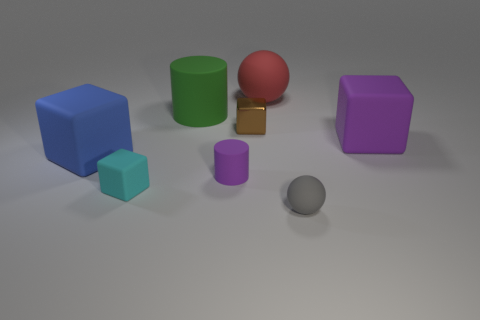Subtract all small rubber blocks. How many blocks are left? 3 Add 1 tiny matte objects. How many objects exist? 9 Subtract all yellow cubes. Subtract all yellow cylinders. How many cubes are left? 4 Subtract all spheres. How many objects are left? 6 Subtract all small brown rubber objects. Subtract all green things. How many objects are left? 7 Add 3 big cylinders. How many big cylinders are left? 4 Add 4 small gray balls. How many small gray balls exist? 5 Subtract 0 green blocks. How many objects are left? 8 